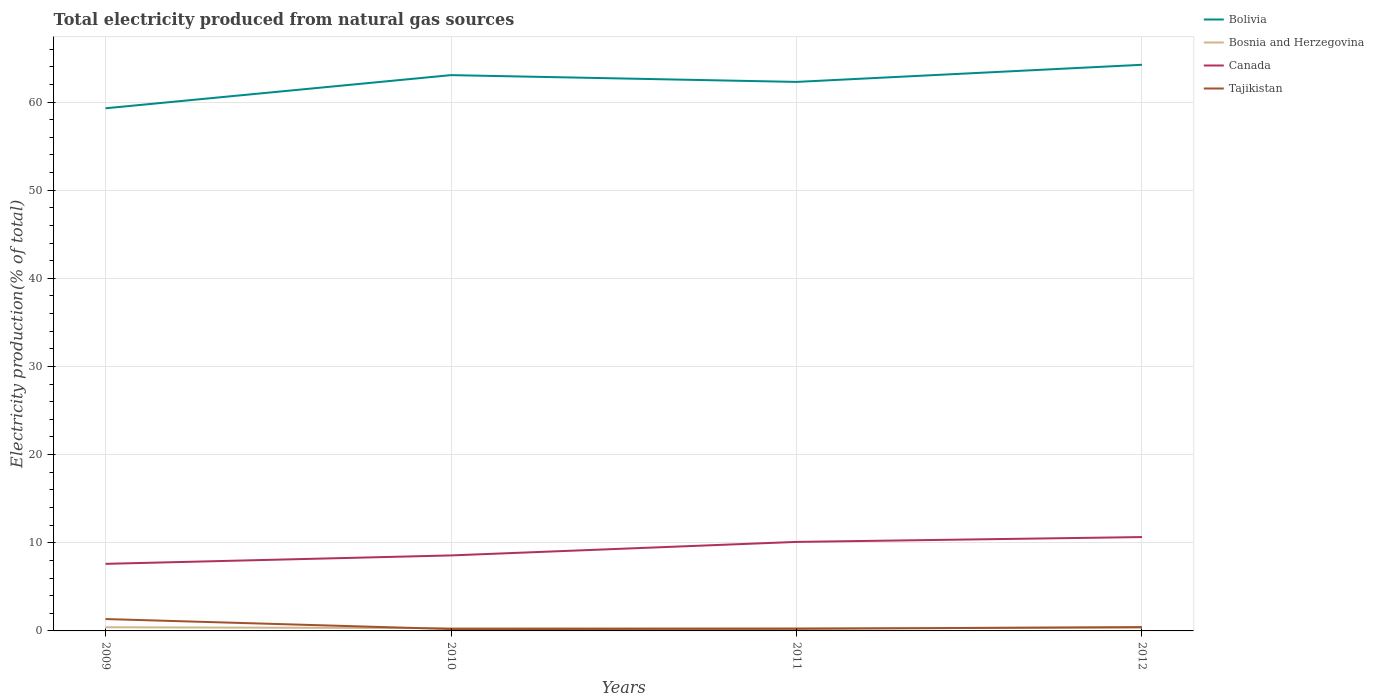How many different coloured lines are there?
Your response must be concise. 4. Is the number of lines equal to the number of legend labels?
Your answer should be very brief. Yes. Across all years, what is the maximum total electricity produced in Tajikistan?
Provide a succinct answer. 0.21. In which year was the total electricity produced in Bosnia and Herzegovina maximum?
Keep it short and to the point. 2010. What is the total total electricity produced in Bolivia in the graph?
Offer a terse response. -4.93. What is the difference between the highest and the second highest total electricity produced in Bolivia?
Offer a very short reply. 4.93. Is the total electricity produced in Bolivia strictly greater than the total electricity produced in Canada over the years?
Provide a succinct answer. No. How many lines are there?
Your answer should be compact. 4. How many years are there in the graph?
Your response must be concise. 4. What is the difference between two consecutive major ticks on the Y-axis?
Your answer should be compact. 10. How many legend labels are there?
Make the answer very short. 4. How are the legend labels stacked?
Your answer should be compact. Vertical. What is the title of the graph?
Make the answer very short. Total electricity produced from natural gas sources. What is the label or title of the X-axis?
Offer a very short reply. Years. What is the Electricity production(% of total) in Bolivia in 2009?
Offer a terse response. 59.29. What is the Electricity production(% of total) of Bosnia and Herzegovina in 2009?
Offer a terse response. 0.41. What is the Electricity production(% of total) in Canada in 2009?
Give a very brief answer. 7.61. What is the Electricity production(% of total) of Tajikistan in 2009?
Offer a very short reply. 1.35. What is the Electricity production(% of total) of Bolivia in 2010?
Offer a very short reply. 63.05. What is the Electricity production(% of total) of Bosnia and Herzegovina in 2010?
Give a very brief answer. 0.32. What is the Electricity production(% of total) in Canada in 2010?
Your answer should be very brief. 8.56. What is the Electricity production(% of total) in Tajikistan in 2010?
Ensure brevity in your answer.  0.21. What is the Electricity production(% of total) in Bolivia in 2011?
Give a very brief answer. 62.28. What is the Electricity production(% of total) in Bosnia and Herzegovina in 2011?
Offer a very short reply. 0.32. What is the Electricity production(% of total) of Canada in 2011?
Keep it short and to the point. 10.1. What is the Electricity production(% of total) of Tajikistan in 2011?
Make the answer very short. 0.23. What is the Electricity production(% of total) in Bolivia in 2012?
Provide a short and direct response. 64.22. What is the Electricity production(% of total) in Bosnia and Herzegovina in 2012?
Provide a short and direct response. 0.37. What is the Electricity production(% of total) in Canada in 2012?
Offer a terse response. 10.65. What is the Electricity production(% of total) in Tajikistan in 2012?
Your answer should be compact. 0.44. Across all years, what is the maximum Electricity production(% of total) in Bolivia?
Give a very brief answer. 64.22. Across all years, what is the maximum Electricity production(% of total) in Bosnia and Herzegovina?
Provide a succinct answer. 0.41. Across all years, what is the maximum Electricity production(% of total) of Canada?
Your answer should be compact. 10.65. Across all years, what is the maximum Electricity production(% of total) of Tajikistan?
Your answer should be compact. 1.35. Across all years, what is the minimum Electricity production(% of total) in Bolivia?
Provide a short and direct response. 59.29. Across all years, what is the minimum Electricity production(% of total) in Bosnia and Herzegovina?
Provide a short and direct response. 0.32. Across all years, what is the minimum Electricity production(% of total) of Canada?
Keep it short and to the point. 7.61. Across all years, what is the minimum Electricity production(% of total) in Tajikistan?
Your answer should be compact. 0.21. What is the total Electricity production(% of total) in Bolivia in the graph?
Offer a very short reply. 248.84. What is the total Electricity production(% of total) of Bosnia and Herzegovina in the graph?
Offer a very short reply. 1.42. What is the total Electricity production(% of total) of Canada in the graph?
Give a very brief answer. 36.92. What is the total Electricity production(% of total) of Tajikistan in the graph?
Your answer should be compact. 2.23. What is the difference between the Electricity production(% of total) in Bolivia in 2009 and that in 2010?
Make the answer very short. -3.76. What is the difference between the Electricity production(% of total) of Bosnia and Herzegovina in 2009 and that in 2010?
Keep it short and to the point. 0.1. What is the difference between the Electricity production(% of total) of Canada in 2009 and that in 2010?
Offer a terse response. -0.95. What is the difference between the Electricity production(% of total) of Tajikistan in 2009 and that in 2010?
Offer a very short reply. 1.13. What is the difference between the Electricity production(% of total) of Bolivia in 2009 and that in 2011?
Your response must be concise. -2.99. What is the difference between the Electricity production(% of total) in Bosnia and Herzegovina in 2009 and that in 2011?
Make the answer very short. 0.09. What is the difference between the Electricity production(% of total) in Canada in 2009 and that in 2011?
Ensure brevity in your answer.  -2.49. What is the difference between the Electricity production(% of total) in Tajikistan in 2009 and that in 2011?
Provide a succinct answer. 1.11. What is the difference between the Electricity production(% of total) in Bolivia in 2009 and that in 2012?
Keep it short and to the point. -4.93. What is the difference between the Electricity production(% of total) of Bosnia and Herzegovina in 2009 and that in 2012?
Give a very brief answer. 0.05. What is the difference between the Electricity production(% of total) of Canada in 2009 and that in 2012?
Offer a terse response. -3.04. What is the difference between the Electricity production(% of total) in Tajikistan in 2009 and that in 2012?
Offer a terse response. 0.91. What is the difference between the Electricity production(% of total) of Bolivia in 2010 and that in 2011?
Offer a very short reply. 0.77. What is the difference between the Electricity production(% of total) in Bosnia and Herzegovina in 2010 and that in 2011?
Your answer should be compact. -0.01. What is the difference between the Electricity production(% of total) in Canada in 2010 and that in 2011?
Make the answer very short. -1.53. What is the difference between the Electricity production(% of total) of Tajikistan in 2010 and that in 2011?
Give a very brief answer. -0.02. What is the difference between the Electricity production(% of total) of Bolivia in 2010 and that in 2012?
Offer a very short reply. -1.17. What is the difference between the Electricity production(% of total) in Bosnia and Herzegovina in 2010 and that in 2012?
Your answer should be compact. -0.05. What is the difference between the Electricity production(% of total) in Canada in 2010 and that in 2012?
Keep it short and to the point. -2.08. What is the difference between the Electricity production(% of total) in Tajikistan in 2010 and that in 2012?
Your answer should be compact. -0.22. What is the difference between the Electricity production(% of total) of Bolivia in 2011 and that in 2012?
Your answer should be very brief. -1.94. What is the difference between the Electricity production(% of total) of Bosnia and Herzegovina in 2011 and that in 2012?
Offer a terse response. -0.05. What is the difference between the Electricity production(% of total) in Canada in 2011 and that in 2012?
Your answer should be compact. -0.55. What is the difference between the Electricity production(% of total) in Tajikistan in 2011 and that in 2012?
Ensure brevity in your answer.  -0.2. What is the difference between the Electricity production(% of total) of Bolivia in 2009 and the Electricity production(% of total) of Bosnia and Herzegovina in 2010?
Provide a short and direct response. 58.97. What is the difference between the Electricity production(% of total) in Bolivia in 2009 and the Electricity production(% of total) in Canada in 2010?
Give a very brief answer. 50.72. What is the difference between the Electricity production(% of total) of Bolivia in 2009 and the Electricity production(% of total) of Tajikistan in 2010?
Make the answer very short. 59.07. What is the difference between the Electricity production(% of total) in Bosnia and Herzegovina in 2009 and the Electricity production(% of total) in Canada in 2010?
Keep it short and to the point. -8.15. What is the difference between the Electricity production(% of total) in Bosnia and Herzegovina in 2009 and the Electricity production(% of total) in Tajikistan in 2010?
Your answer should be compact. 0.2. What is the difference between the Electricity production(% of total) in Canada in 2009 and the Electricity production(% of total) in Tajikistan in 2010?
Your answer should be very brief. 7.4. What is the difference between the Electricity production(% of total) of Bolivia in 2009 and the Electricity production(% of total) of Bosnia and Herzegovina in 2011?
Your answer should be very brief. 58.97. What is the difference between the Electricity production(% of total) of Bolivia in 2009 and the Electricity production(% of total) of Canada in 2011?
Keep it short and to the point. 49.19. What is the difference between the Electricity production(% of total) of Bolivia in 2009 and the Electricity production(% of total) of Tajikistan in 2011?
Ensure brevity in your answer.  59.05. What is the difference between the Electricity production(% of total) in Bosnia and Herzegovina in 2009 and the Electricity production(% of total) in Canada in 2011?
Provide a short and direct response. -9.68. What is the difference between the Electricity production(% of total) in Bosnia and Herzegovina in 2009 and the Electricity production(% of total) in Tajikistan in 2011?
Provide a succinct answer. 0.18. What is the difference between the Electricity production(% of total) of Canada in 2009 and the Electricity production(% of total) of Tajikistan in 2011?
Keep it short and to the point. 7.38. What is the difference between the Electricity production(% of total) in Bolivia in 2009 and the Electricity production(% of total) in Bosnia and Herzegovina in 2012?
Your answer should be very brief. 58.92. What is the difference between the Electricity production(% of total) of Bolivia in 2009 and the Electricity production(% of total) of Canada in 2012?
Offer a terse response. 48.64. What is the difference between the Electricity production(% of total) in Bolivia in 2009 and the Electricity production(% of total) in Tajikistan in 2012?
Offer a terse response. 58.85. What is the difference between the Electricity production(% of total) of Bosnia and Herzegovina in 2009 and the Electricity production(% of total) of Canada in 2012?
Provide a short and direct response. -10.23. What is the difference between the Electricity production(% of total) in Bosnia and Herzegovina in 2009 and the Electricity production(% of total) in Tajikistan in 2012?
Your response must be concise. -0.02. What is the difference between the Electricity production(% of total) in Canada in 2009 and the Electricity production(% of total) in Tajikistan in 2012?
Make the answer very short. 7.17. What is the difference between the Electricity production(% of total) in Bolivia in 2010 and the Electricity production(% of total) in Bosnia and Herzegovina in 2011?
Offer a terse response. 62.73. What is the difference between the Electricity production(% of total) of Bolivia in 2010 and the Electricity production(% of total) of Canada in 2011?
Provide a short and direct response. 52.95. What is the difference between the Electricity production(% of total) of Bolivia in 2010 and the Electricity production(% of total) of Tajikistan in 2011?
Offer a terse response. 62.81. What is the difference between the Electricity production(% of total) in Bosnia and Herzegovina in 2010 and the Electricity production(% of total) in Canada in 2011?
Keep it short and to the point. -9.78. What is the difference between the Electricity production(% of total) in Bosnia and Herzegovina in 2010 and the Electricity production(% of total) in Tajikistan in 2011?
Your answer should be compact. 0.08. What is the difference between the Electricity production(% of total) in Canada in 2010 and the Electricity production(% of total) in Tajikistan in 2011?
Provide a short and direct response. 8.33. What is the difference between the Electricity production(% of total) of Bolivia in 2010 and the Electricity production(% of total) of Bosnia and Herzegovina in 2012?
Offer a very short reply. 62.68. What is the difference between the Electricity production(% of total) in Bolivia in 2010 and the Electricity production(% of total) in Canada in 2012?
Give a very brief answer. 52.4. What is the difference between the Electricity production(% of total) of Bolivia in 2010 and the Electricity production(% of total) of Tajikistan in 2012?
Provide a short and direct response. 62.61. What is the difference between the Electricity production(% of total) in Bosnia and Herzegovina in 2010 and the Electricity production(% of total) in Canada in 2012?
Your response must be concise. -10.33. What is the difference between the Electricity production(% of total) of Bosnia and Herzegovina in 2010 and the Electricity production(% of total) of Tajikistan in 2012?
Give a very brief answer. -0.12. What is the difference between the Electricity production(% of total) of Canada in 2010 and the Electricity production(% of total) of Tajikistan in 2012?
Keep it short and to the point. 8.13. What is the difference between the Electricity production(% of total) in Bolivia in 2011 and the Electricity production(% of total) in Bosnia and Herzegovina in 2012?
Offer a very short reply. 61.91. What is the difference between the Electricity production(% of total) of Bolivia in 2011 and the Electricity production(% of total) of Canada in 2012?
Make the answer very short. 51.63. What is the difference between the Electricity production(% of total) in Bolivia in 2011 and the Electricity production(% of total) in Tajikistan in 2012?
Provide a short and direct response. 61.84. What is the difference between the Electricity production(% of total) in Bosnia and Herzegovina in 2011 and the Electricity production(% of total) in Canada in 2012?
Keep it short and to the point. -10.33. What is the difference between the Electricity production(% of total) of Bosnia and Herzegovina in 2011 and the Electricity production(% of total) of Tajikistan in 2012?
Make the answer very short. -0.12. What is the difference between the Electricity production(% of total) in Canada in 2011 and the Electricity production(% of total) in Tajikistan in 2012?
Make the answer very short. 9.66. What is the average Electricity production(% of total) in Bolivia per year?
Your answer should be very brief. 62.21. What is the average Electricity production(% of total) of Bosnia and Herzegovina per year?
Provide a short and direct response. 0.35. What is the average Electricity production(% of total) in Canada per year?
Your response must be concise. 9.23. What is the average Electricity production(% of total) of Tajikistan per year?
Provide a succinct answer. 0.56. In the year 2009, what is the difference between the Electricity production(% of total) of Bolivia and Electricity production(% of total) of Bosnia and Herzegovina?
Make the answer very short. 58.87. In the year 2009, what is the difference between the Electricity production(% of total) of Bolivia and Electricity production(% of total) of Canada?
Offer a terse response. 51.68. In the year 2009, what is the difference between the Electricity production(% of total) of Bolivia and Electricity production(% of total) of Tajikistan?
Keep it short and to the point. 57.94. In the year 2009, what is the difference between the Electricity production(% of total) of Bosnia and Herzegovina and Electricity production(% of total) of Canada?
Keep it short and to the point. -7.19. In the year 2009, what is the difference between the Electricity production(% of total) in Bosnia and Herzegovina and Electricity production(% of total) in Tajikistan?
Keep it short and to the point. -0.93. In the year 2009, what is the difference between the Electricity production(% of total) of Canada and Electricity production(% of total) of Tajikistan?
Your answer should be very brief. 6.26. In the year 2010, what is the difference between the Electricity production(% of total) in Bolivia and Electricity production(% of total) in Bosnia and Herzegovina?
Keep it short and to the point. 62.73. In the year 2010, what is the difference between the Electricity production(% of total) in Bolivia and Electricity production(% of total) in Canada?
Offer a very short reply. 54.48. In the year 2010, what is the difference between the Electricity production(% of total) in Bolivia and Electricity production(% of total) in Tajikistan?
Your answer should be compact. 62.84. In the year 2010, what is the difference between the Electricity production(% of total) in Bosnia and Herzegovina and Electricity production(% of total) in Canada?
Your answer should be very brief. -8.25. In the year 2010, what is the difference between the Electricity production(% of total) of Bosnia and Herzegovina and Electricity production(% of total) of Tajikistan?
Ensure brevity in your answer.  0.1. In the year 2010, what is the difference between the Electricity production(% of total) of Canada and Electricity production(% of total) of Tajikistan?
Keep it short and to the point. 8.35. In the year 2011, what is the difference between the Electricity production(% of total) in Bolivia and Electricity production(% of total) in Bosnia and Herzegovina?
Provide a short and direct response. 61.96. In the year 2011, what is the difference between the Electricity production(% of total) of Bolivia and Electricity production(% of total) of Canada?
Provide a short and direct response. 52.18. In the year 2011, what is the difference between the Electricity production(% of total) in Bolivia and Electricity production(% of total) in Tajikistan?
Your response must be concise. 62.05. In the year 2011, what is the difference between the Electricity production(% of total) of Bosnia and Herzegovina and Electricity production(% of total) of Canada?
Offer a terse response. -9.78. In the year 2011, what is the difference between the Electricity production(% of total) of Bosnia and Herzegovina and Electricity production(% of total) of Tajikistan?
Your answer should be very brief. 0.09. In the year 2011, what is the difference between the Electricity production(% of total) in Canada and Electricity production(% of total) in Tajikistan?
Offer a terse response. 9.86. In the year 2012, what is the difference between the Electricity production(% of total) of Bolivia and Electricity production(% of total) of Bosnia and Herzegovina?
Offer a very short reply. 63.85. In the year 2012, what is the difference between the Electricity production(% of total) of Bolivia and Electricity production(% of total) of Canada?
Provide a short and direct response. 53.57. In the year 2012, what is the difference between the Electricity production(% of total) of Bolivia and Electricity production(% of total) of Tajikistan?
Your response must be concise. 63.79. In the year 2012, what is the difference between the Electricity production(% of total) in Bosnia and Herzegovina and Electricity production(% of total) in Canada?
Give a very brief answer. -10.28. In the year 2012, what is the difference between the Electricity production(% of total) in Bosnia and Herzegovina and Electricity production(% of total) in Tajikistan?
Offer a very short reply. -0.07. In the year 2012, what is the difference between the Electricity production(% of total) of Canada and Electricity production(% of total) of Tajikistan?
Keep it short and to the point. 10.21. What is the ratio of the Electricity production(% of total) in Bolivia in 2009 to that in 2010?
Your answer should be compact. 0.94. What is the ratio of the Electricity production(% of total) in Bosnia and Herzegovina in 2009 to that in 2010?
Provide a short and direct response. 1.32. What is the ratio of the Electricity production(% of total) in Canada in 2009 to that in 2010?
Ensure brevity in your answer.  0.89. What is the ratio of the Electricity production(% of total) in Tajikistan in 2009 to that in 2010?
Offer a very short reply. 6.32. What is the ratio of the Electricity production(% of total) in Bolivia in 2009 to that in 2011?
Your answer should be very brief. 0.95. What is the ratio of the Electricity production(% of total) of Bosnia and Herzegovina in 2009 to that in 2011?
Offer a very short reply. 1.29. What is the ratio of the Electricity production(% of total) of Canada in 2009 to that in 2011?
Offer a terse response. 0.75. What is the ratio of the Electricity production(% of total) of Tajikistan in 2009 to that in 2011?
Your response must be concise. 5.75. What is the ratio of the Electricity production(% of total) of Bolivia in 2009 to that in 2012?
Your answer should be very brief. 0.92. What is the ratio of the Electricity production(% of total) of Bosnia and Herzegovina in 2009 to that in 2012?
Provide a succinct answer. 1.12. What is the ratio of the Electricity production(% of total) of Canada in 2009 to that in 2012?
Keep it short and to the point. 0.71. What is the ratio of the Electricity production(% of total) of Tajikistan in 2009 to that in 2012?
Offer a terse response. 3.09. What is the ratio of the Electricity production(% of total) of Bolivia in 2010 to that in 2011?
Offer a terse response. 1.01. What is the ratio of the Electricity production(% of total) of Bosnia and Herzegovina in 2010 to that in 2011?
Your answer should be compact. 0.98. What is the ratio of the Electricity production(% of total) in Canada in 2010 to that in 2011?
Offer a terse response. 0.85. What is the ratio of the Electricity production(% of total) in Tajikistan in 2010 to that in 2011?
Keep it short and to the point. 0.91. What is the ratio of the Electricity production(% of total) in Bolivia in 2010 to that in 2012?
Make the answer very short. 0.98. What is the ratio of the Electricity production(% of total) in Bosnia and Herzegovina in 2010 to that in 2012?
Ensure brevity in your answer.  0.85. What is the ratio of the Electricity production(% of total) of Canada in 2010 to that in 2012?
Make the answer very short. 0.8. What is the ratio of the Electricity production(% of total) in Tajikistan in 2010 to that in 2012?
Ensure brevity in your answer.  0.49. What is the ratio of the Electricity production(% of total) in Bolivia in 2011 to that in 2012?
Offer a terse response. 0.97. What is the ratio of the Electricity production(% of total) in Bosnia and Herzegovina in 2011 to that in 2012?
Give a very brief answer. 0.87. What is the ratio of the Electricity production(% of total) of Canada in 2011 to that in 2012?
Offer a terse response. 0.95. What is the ratio of the Electricity production(% of total) of Tajikistan in 2011 to that in 2012?
Provide a succinct answer. 0.54. What is the difference between the highest and the second highest Electricity production(% of total) in Bolivia?
Your response must be concise. 1.17. What is the difference between the highest and the second highest Electricity production(% of total) in Bosnia and Herzegovina?
Provide a short and direct response. 0.05. What is the difference between the highest and the second highest Electricity production(% of total) of Canada?
Your response must be concise. 0.55. What is the difference between the highest and the second highest Electricity production(% of total) of Tajikistan?
Make the answer very short. 0.91. What is the difference between the highest and the lowest Electricity production(% of total) in Bolivia?
Offer a terse response. 4.93. What is the difference between the highest and the lowest Electricity production(% of total) in Bosnia and Herzegovina?
Make the answer very short. 0.1. What is the difference between the highest and the lowest Electricity production(% of total) of Canada?
Offer a very short reply. 3.04. What is the difference between the highest and the lowest Electricity production(% of total) in Tajikistan?
Ensure brevity in your answer.  1.13. 